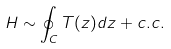Convert formula to latex. <formula><loc_0><loc_0><loc_500><loc_500>H \sim \oint _ { C } T ( z ) d z + c . c .</formula> 